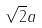Convert formula to latex. <formula><loc_0><loc_0><loc_500><loc_500>\sqrt { 2 } a</formula> 